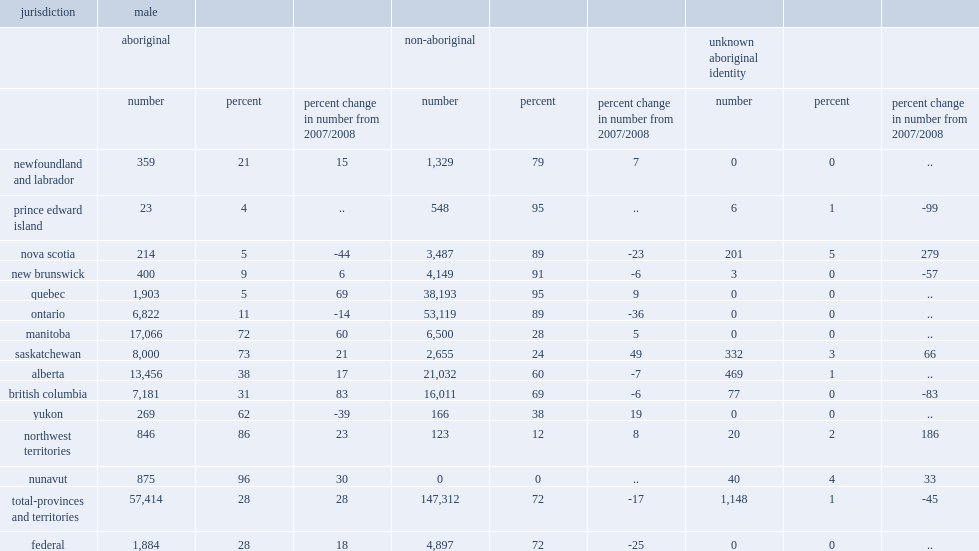What was the percentage of male admissions to custody in the provinces and territories aboriginal males accounted for in 2017/2018? 28.0. What was the change in the number of admissions of aboriginal males to provincial/territorial custody in comparison to 2007/2008? 28.0. What was the change in admissions of aboriginal males in british columbia compared to 2007/2008? 83.0. What was the change in admissions of aboriginal males in quebec compared to 2007/2008? 69.0. What was the change in admissions of aboriginal males in manitoba compared to 2007/2008? 60.0. 